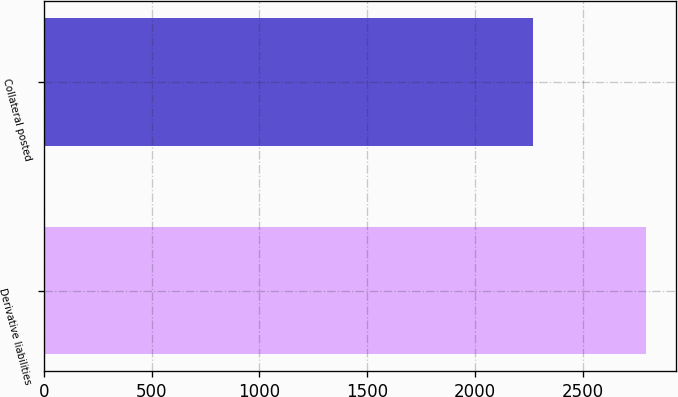Convert chart to OTSL. <chart><loc_0><loc_0><loc_500><loc_500><bar_chart><fcel>Derivative liabilities<fcel>Collateral posted<nl><fcel>2792<fcel>2269<nl></chart> 